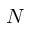Convert formula to latex. <formula><loc_0><loc_0><loc_500><loc_500>N</formula> 